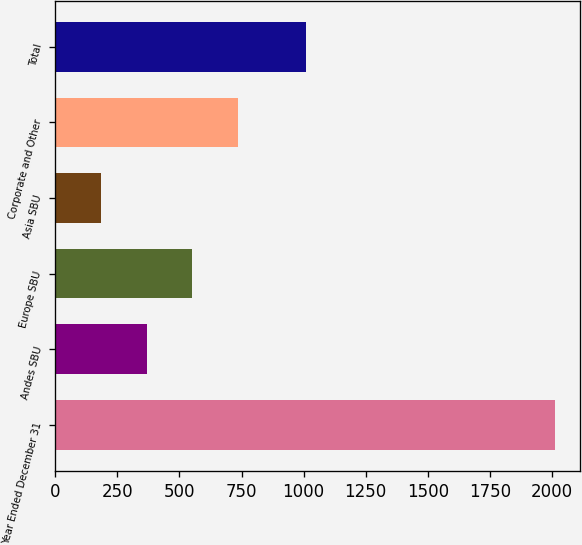<chart> <loc_0><loc_0><loc_500><loc_500><bar_chart><fcel>Year Ended December 31<fcel>Andes SBU<fcel>Europe SBU<fcel>Asia SBU<fcel>Corporate and Other<fcel>Total<nl><fcel>2013<fcel>368.7<fcel>551.4<fcel>186<fcel>734.1<fcel>1010<nl></chart> 